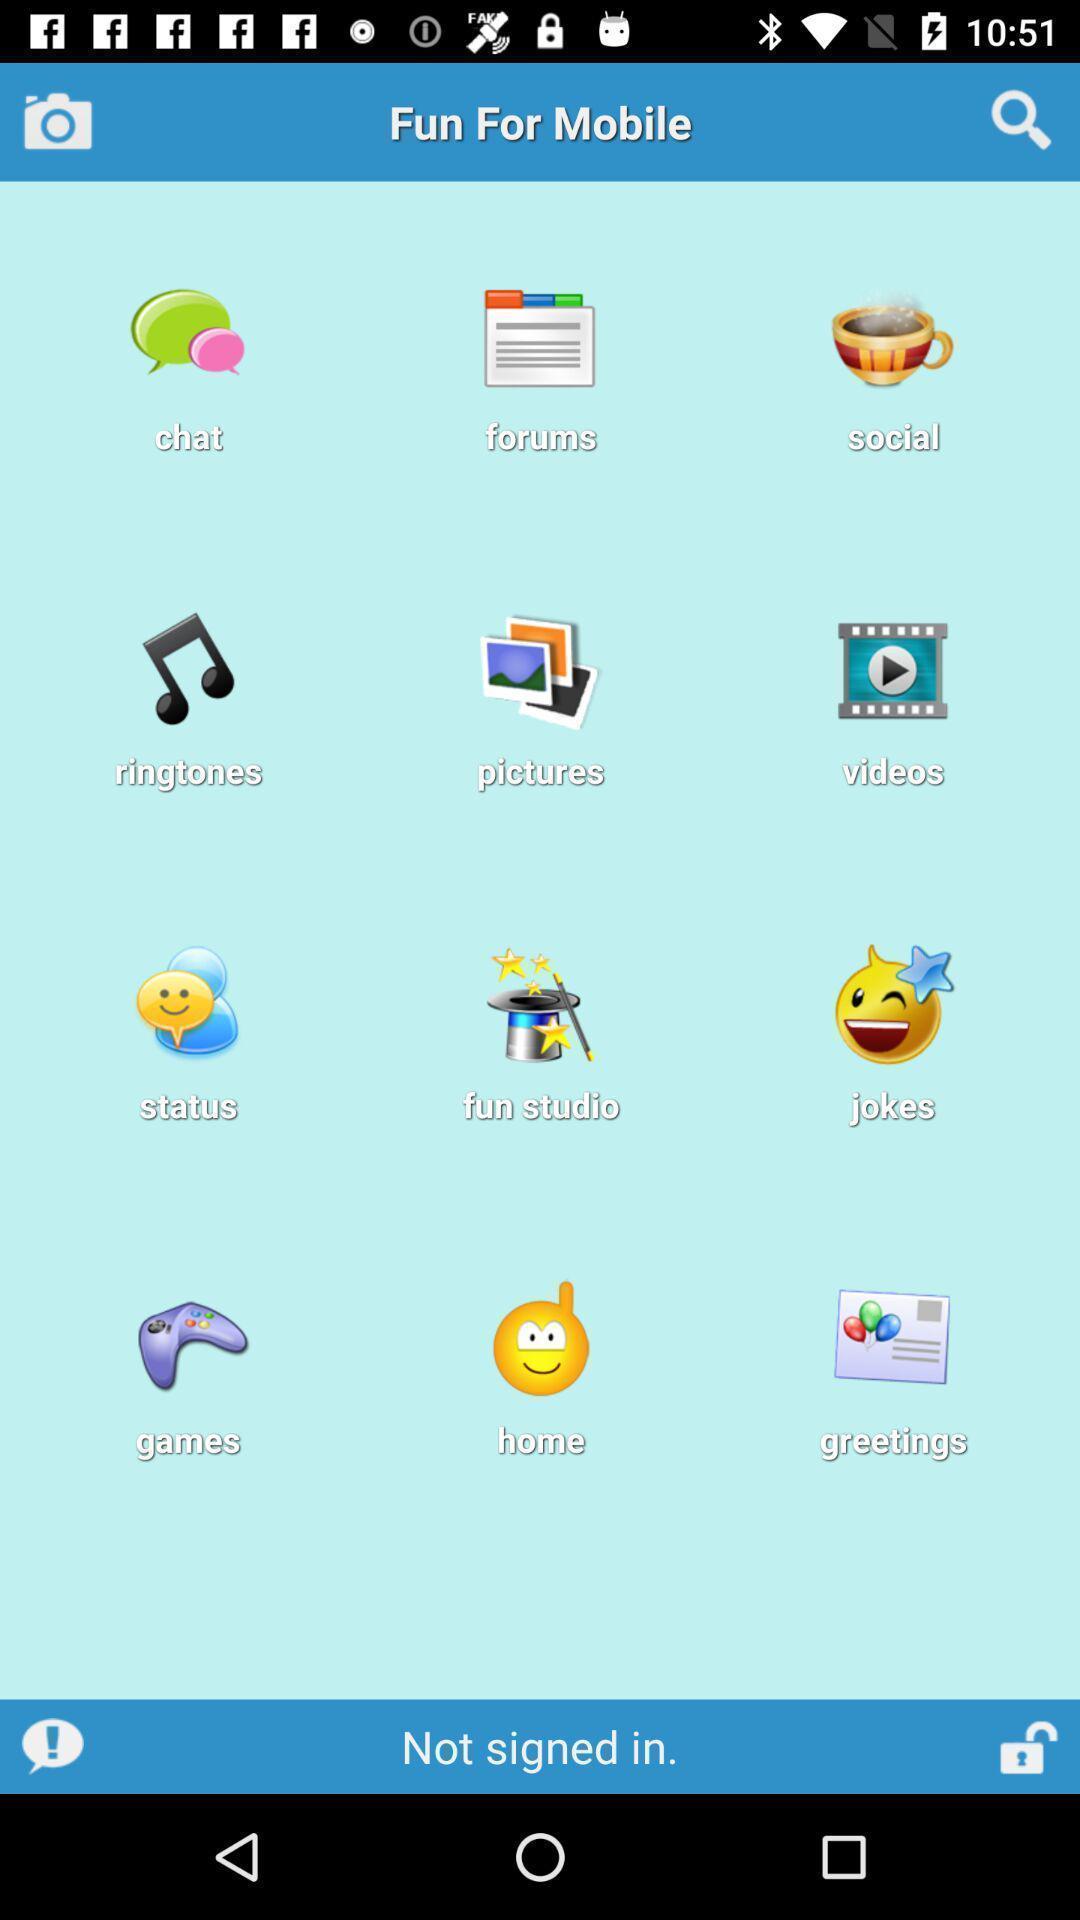Explain what's happening in this screen capture. Screen displaying various options and icons. 